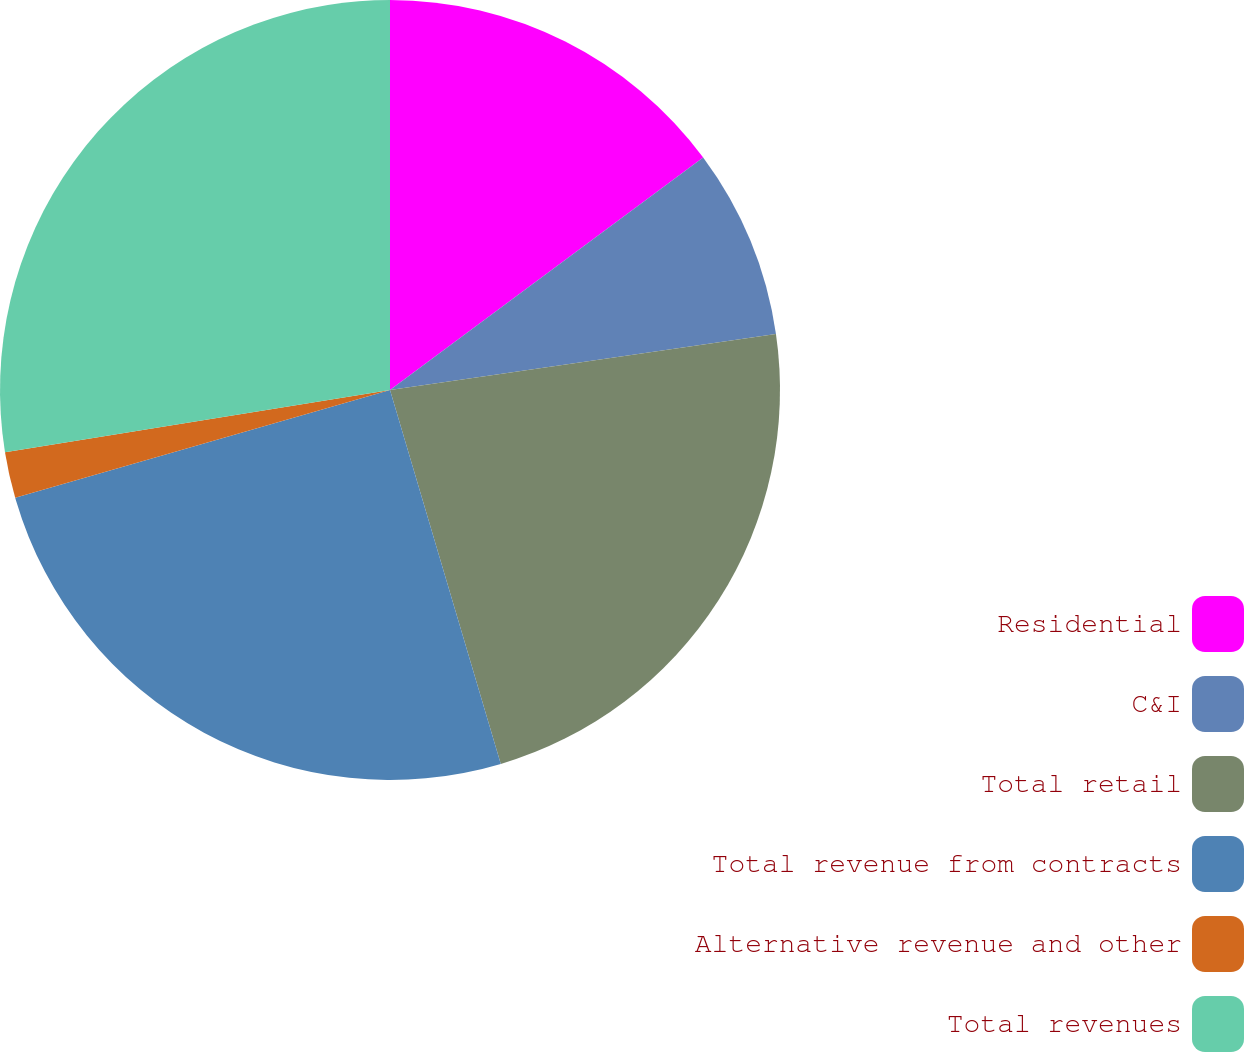<chart> <loc_0><loc_0><loc_500><loc_500><pie_chart><fcel>Residential<fcel>C&I<fcel>Total retail<fcel>Total revenue from contracts<fcel>Alternative revenue and other<fcel>Total revenues<nl><fcel>14.84%<fcel>7.87%<fcel>22.71%<fcel>25.13%<fcel>1.91%<fcel>27.55%<nl></chart> 